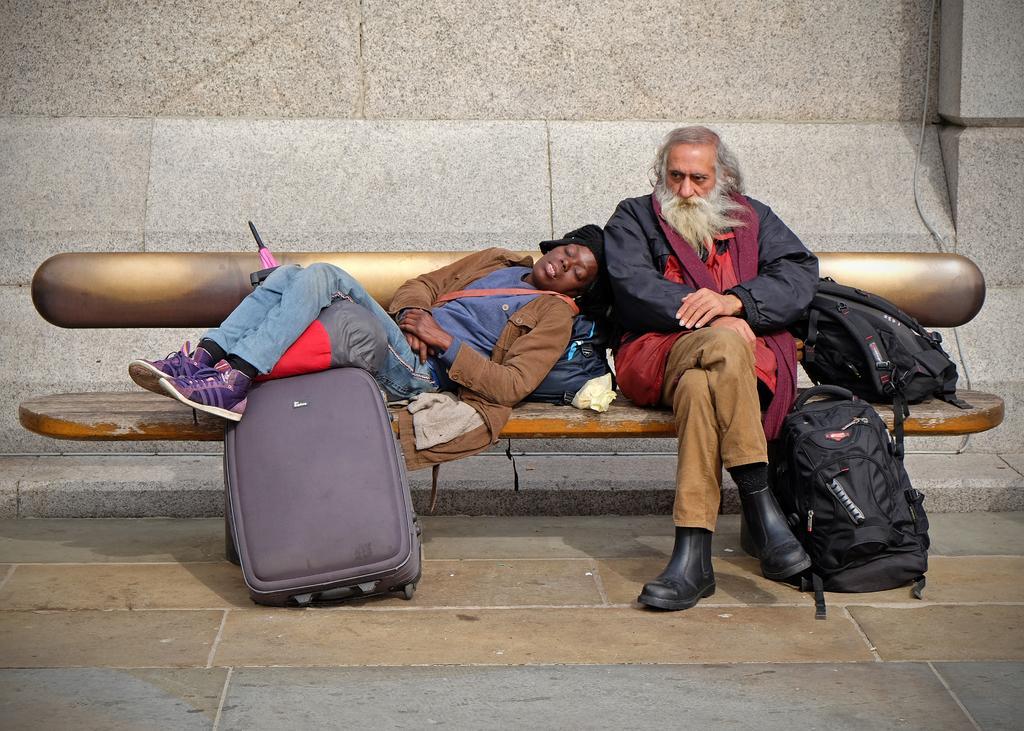Can you describe this image briefly? In the picture we can see a man sitting on a bench and woman laying on him, and we can also see a suite case, a bag, beside a man there is a another bag, in the background we can see a wall. 